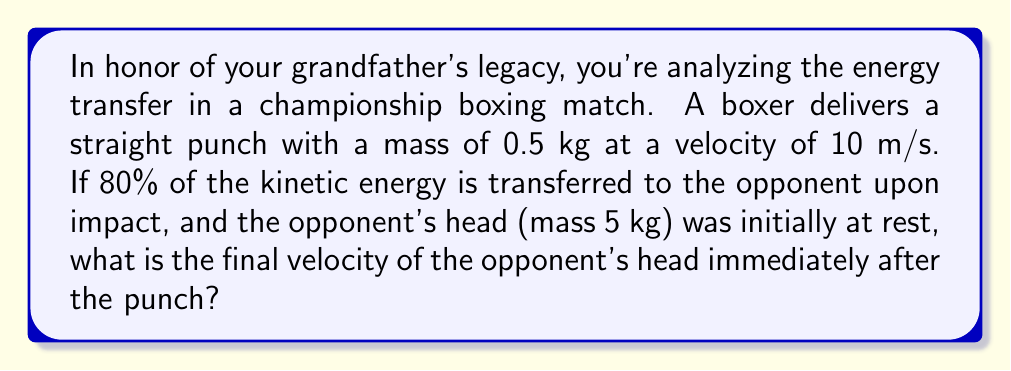Give your solution to this math problem. Let's approach this step-by-step using conservation of energy:

1) First, calculate the initial kinetic energy of the punch:
   $$KE_{initial} = \frac{1}{2}mv^2 = \frac{1}{2}(0.5 \text{ kg})(10 \text{ m/s})^2 = 25 \text{ J}$$

2) The energy transferred to the opponent is 80% of this:
   $$E_{transferred} = 0.80 \times 25 \text{ J} = 20 \text{ J}$$

3) This transferred energy becomes the kinetic energy of the opponent's head:
   $$KE_{final} = 20 \text{ J} = \frac{1}{2}mv^2$$

4) We know the mass of the head (m = 5 kg), so we can solve for v:
   $$20 = \frac{1}{2}(5)v^2$$
   $$40 = 5v^2$$
   $$v^2 = 8$$
   $$v = \sqrt{8} = 2.83 \text{ m/s}$$

Therefore, the final velocity of the opponent's head is approximately 2.83 m/s.
Answer: 2.83 m/s 